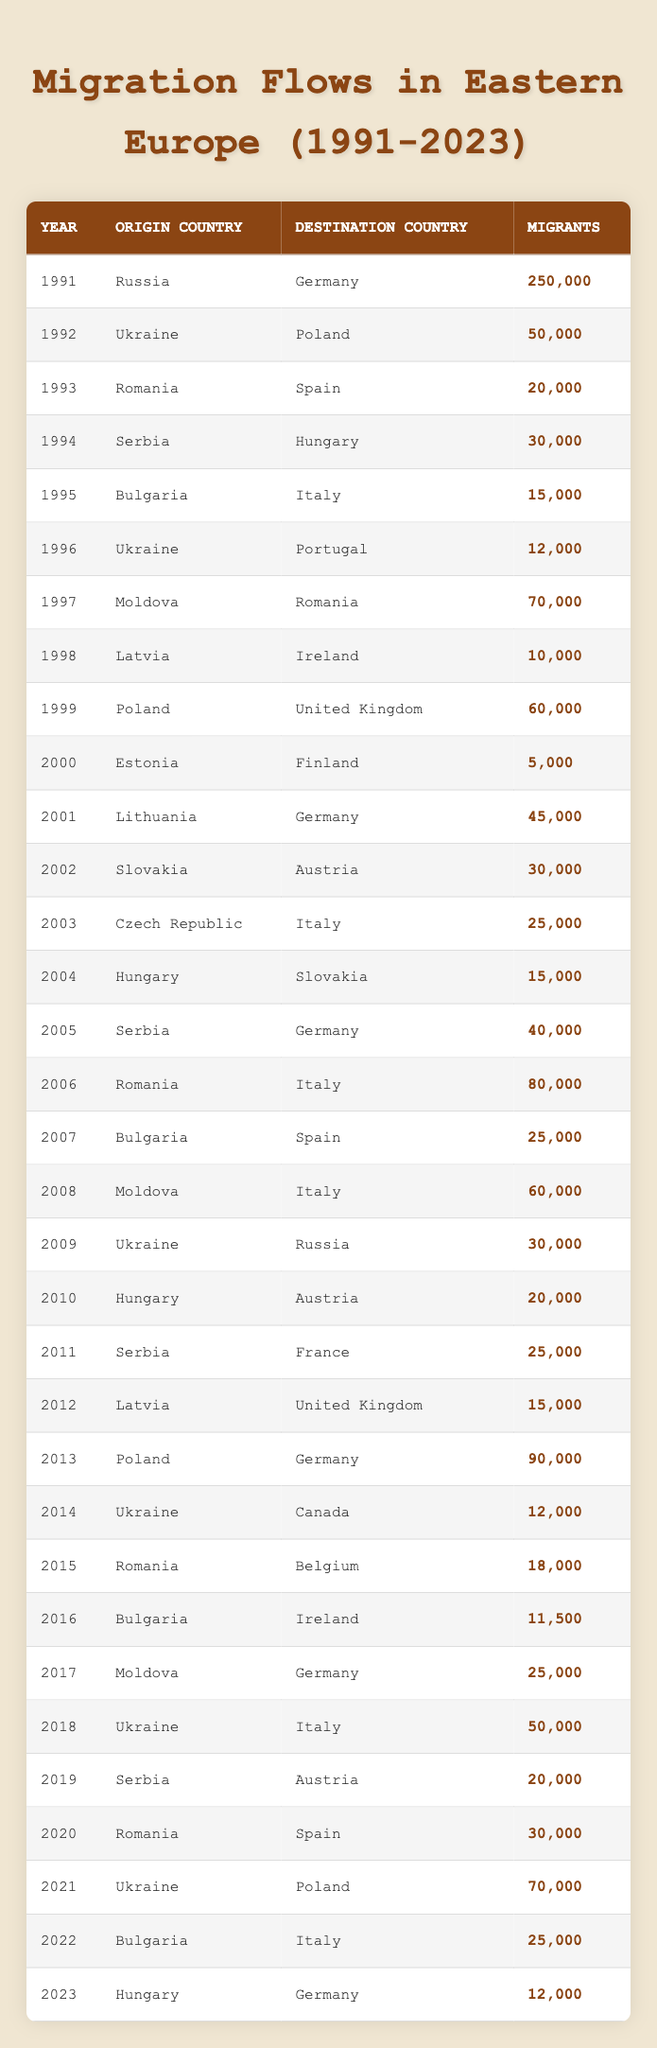What was the number of migrants from Ukraine to Poland in 2021? In 2021, the table lists that there were 70,000 migrants from Ukraine to Poland. This information can be directly retrieved from the corresponding row in the table.
Answer: 70,000 Which country of origin had the highest number of migrants to Germany in 2005? In 2005, Serbia was the country of origin with 40,000 migrants to Germany. This is found by looking at the rows for the year 2005 and identifying the origin country with the highest migrant count.
Answer: Serbia How many migrants moved from Romania to Italy between 2006 and 2022? The number of migrants from Romania to Italy in 2006 was 80,000 and in 2022 it was 25,000. To find the total number of migrants over this period, you sum both values: 80,000 + 25,000 = 105,000.
Answer: 105,000 Did more migrants leave Bulgaria for Italy in 1995 or 2022? In 1995, Bulgaria had 15,000 migrants to Italy, whereas in 2022, there were 25,000. Since 25,000 is greater than 15,000, it confirms that more migrants left Bulgaria for Italy in 2022.
Answer: Yes What was the most common destination country for migrants from Moldova between 1997 and 2017? Analyzing the data for Moldova between 1997 and 2017 shows that in 1997 there were 70,000 migrants to Romania, in 2008 there were 60,000 to Italy, and in 2017 there were 25,000 to Germany. The highest number went to Romania (70,000) in 1997. Thus, the most common destination during this period was Romania.
Answer: Romania What was the average number of migrants from Ukraine to Poland in the years provided? The data shows 50,000 in 1992 and 70,000 in 2021. To calculate the average, you add those two values: 50,000 + 70,000 = 120,000, then divide by the number of entries (2): 120,000 / 2 = 60,000.
Answer: 60,000 How many more migrants moved from Bulgaria to Italy in 2022 compared to the number in 1995? In 1995, there were 15,000 migrants from Bulgaria to Italy, and in 2022, there were 25,000. The difference is calculated by subtracting the earlier figure from the later one: 25,000 - 15,000 = 10,000.
Answer: 10,000 Is it true that more migrants moved from Poland to Germany in 2013 than from Romania to Italy in 2006? In 2013, Poland had 90,000 migrants to Germany, while in 2006, Romania had 80,000 migrants to Italy. Since 90,000 is greater than 80,000, this statement is true.
Answer: Yes 